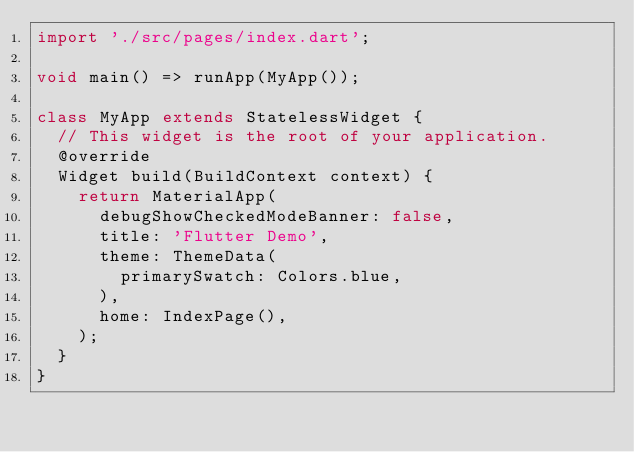<code> <loc_0><loc_0><loc_500><loc_500><_Dart_>import './src/pages/index.dart';

void main() => runApp(MyApp());

class MyApp extends StatelessWidget {
  // This widget is the root of your application.
  @override
  Widget build(BuildContext context) {
    return MaterialApp(
      debugShowCheckedModeBanner: false,
      title: 'Flutter Demo',
      theme: ThemeData(
        primarySwatch: Colors.blue,
      ),
      home: IndexPage(),
    );
  }
}


</code> 